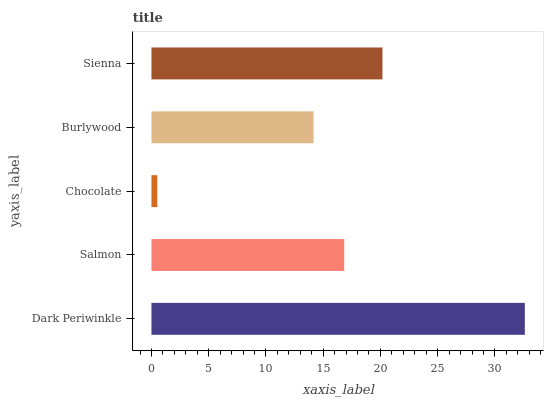Is Chocolate the minimum?
Answer yes or no. Yes. Is Dark Periwinkle the maximum?
Answer yes or no. Yes. Is Salmon the minimum?
Answer yes or no. No. Is Salmon the maximum?
Answer yes or no. No. Is Dark Periwinkle greater than Salmon?
Answer yes or no. Yes. Is Salmon less than Dark Periwinkle?
Answer yes or no. Yes. Is Salmon greater than Dark Periwinkle?
Answer yes or no. No. Is Dark Periwinkle less than Salmon?
Answer yes or no. No. Is Salmon the high median?
Answer yes or no. Yes. Is Salmon the low median?
Answer yes or no. Yes. Is Burlywood the high median?
Answer yes or no. No. Is Burlywood the low median?
Answer yes or no. No. 